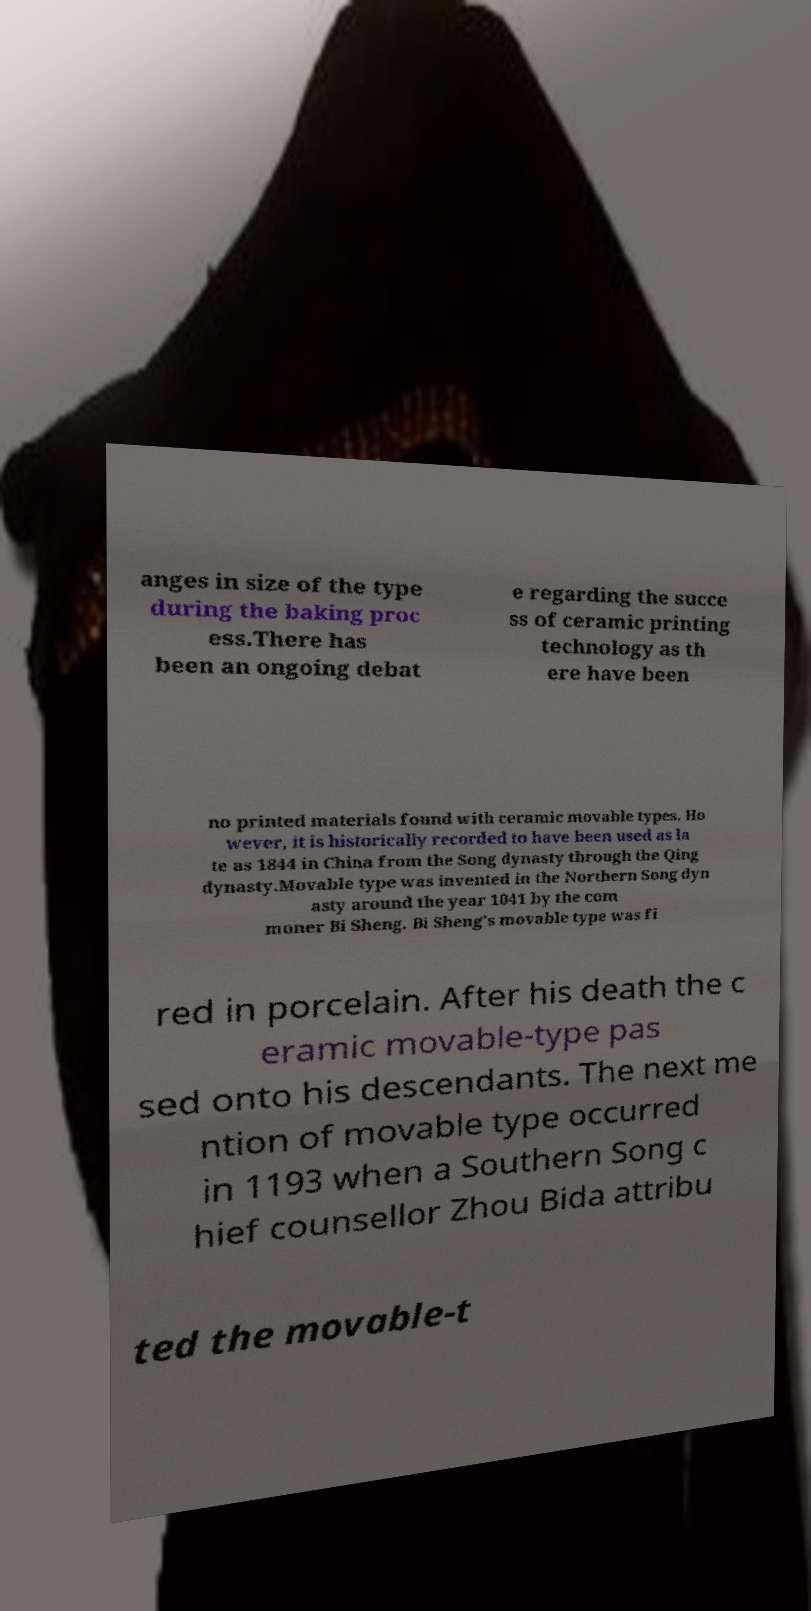Can you read and provide the text displayed in the image?This photo seems to have some interesting text. Can you extract and type it out for me? anges in size of the type during the baking proc ess.There has been an ongoing debat e regarding the succe ss of ceramic printing technology as th ere have been no printed materials found with ceramic movable types. Ho wever, it is historically recorded to have been used as la te as 1844 in China from the Song dynasty through the Qing dynasty.Movable type was invented in the Northern Song dyn asty around the year 1041 by the com moner Bi Sheng. Bi Sheng's movable type was fi red in porcelain. After his death the c eramic movable-type pas sed onto his descendants. The next me ntion of movable type occurred in 1193 when a Southern Song c hief counsellor Zhou Bida attribu ted the movable-t 